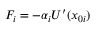Convert formula to latex. <formula><loc_0><loc_0><loc_500><loc_500>F _ { i } = - \alpha _ { i } U ^ { \prime } ( x _ { 0 i } )</formula> 